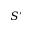Convert formula to latex. <formula><loc_0><loc_0><loc_500><loc_500>S ^ { \prime }</formula> 